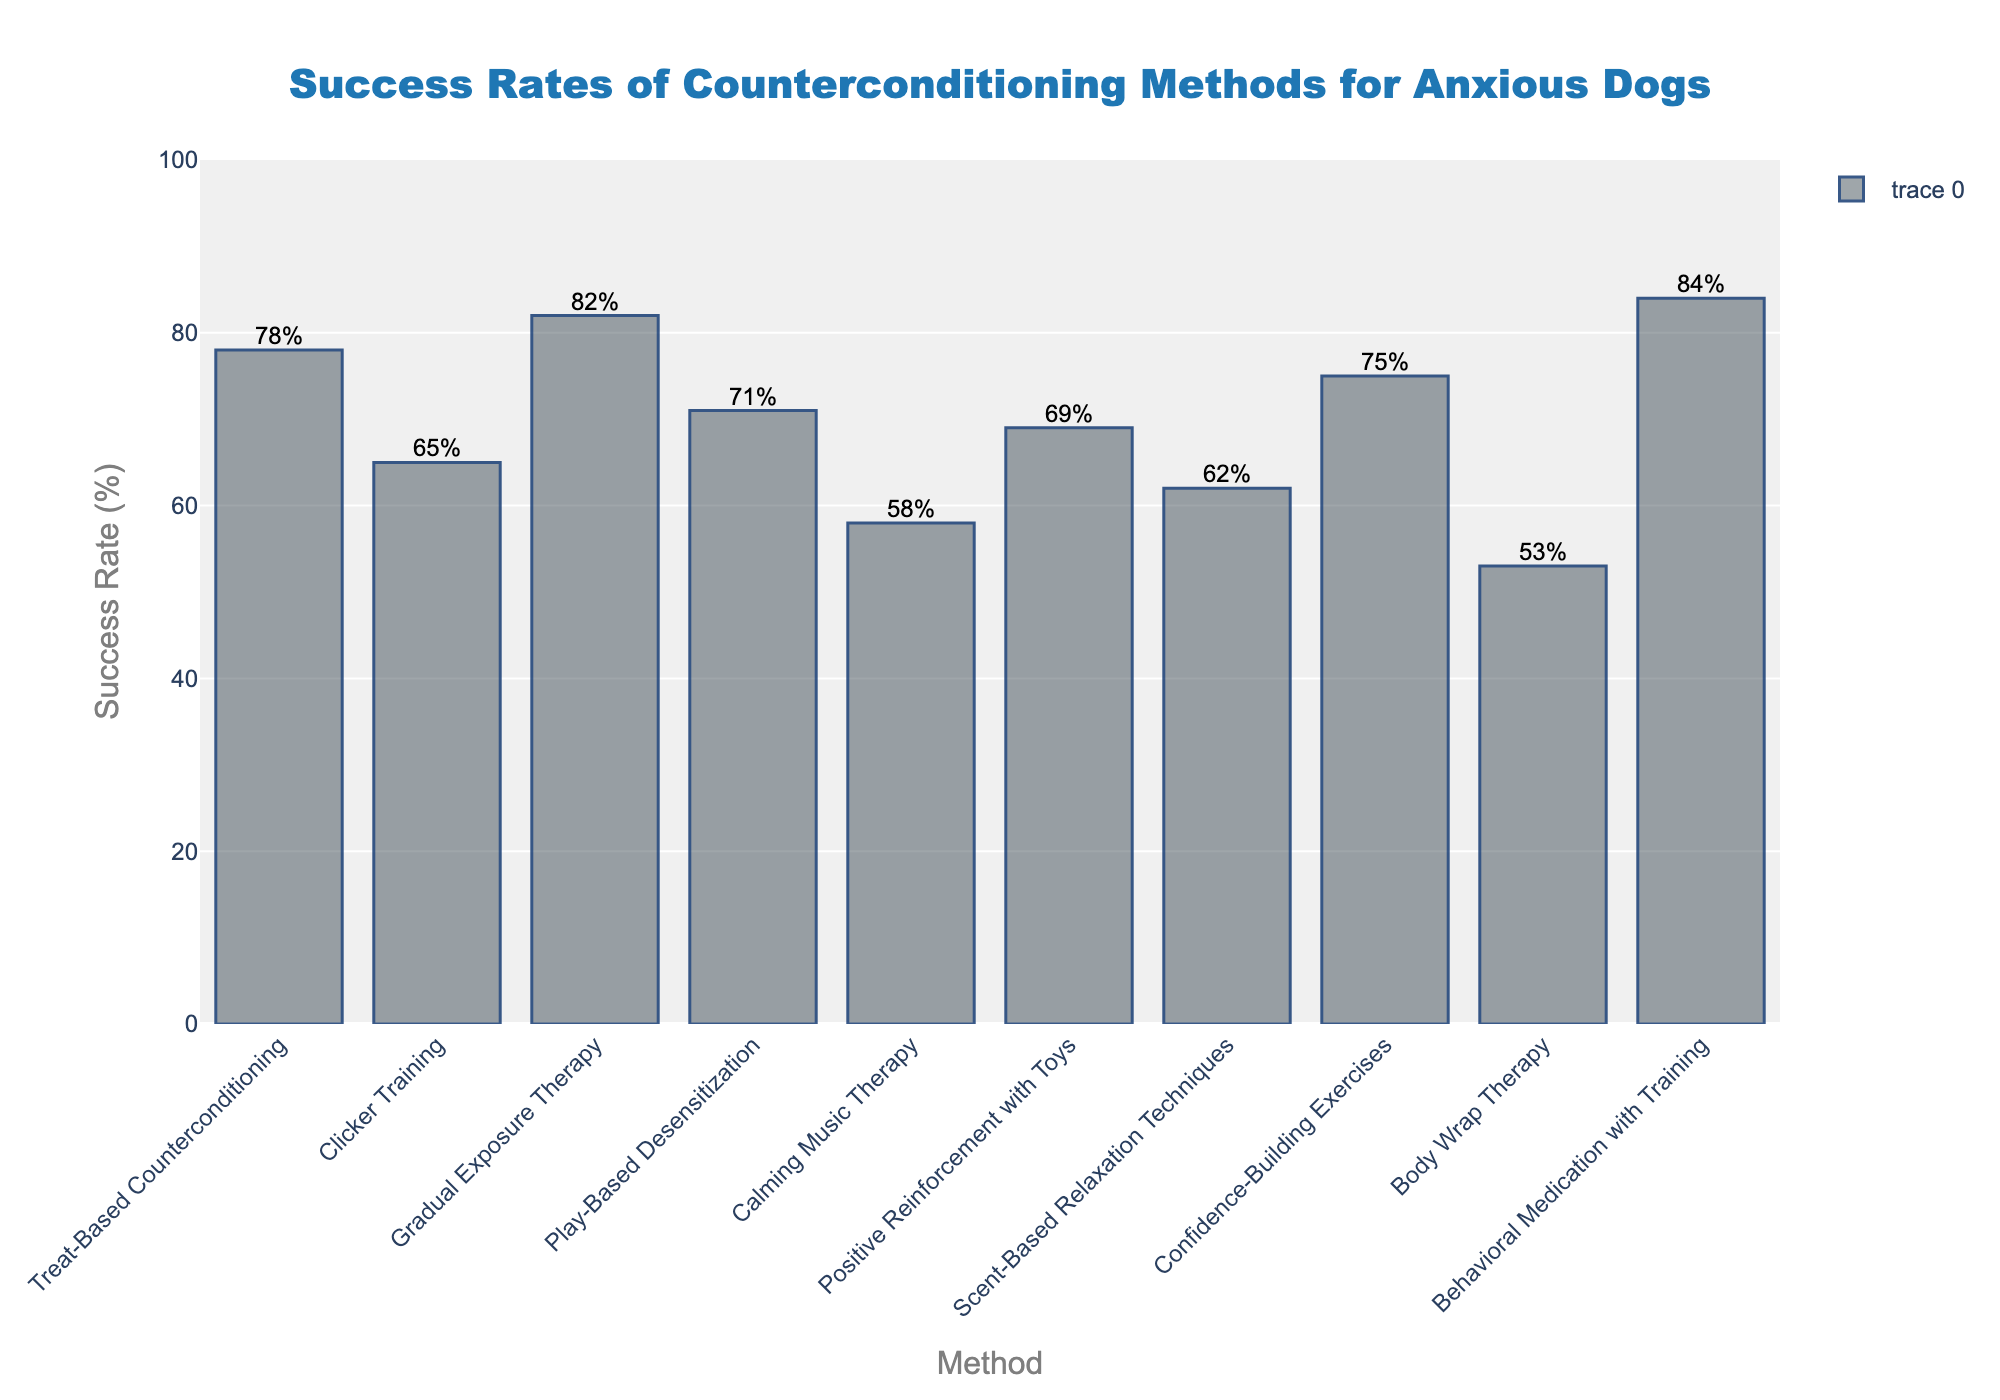What is the method with the highest success rate for counterconditioning? The method with the highest bar in the chart indicates the one with the highest success rate. The bar for Behavioral Medication with Training is the tallest.
Answer: Behavioral Medication with Training Which counterconditioning method has the lowest success rate? The method with the shortest bar represents the lowest success rate. The shortest bar corresponds to Body Wrap Therapy.
Answer: Body Wrap Therapy Which two methods have success rates closest to each other? By visually inspecting the bars of each method, look for two bars that are nearly the same height. Positive Reinforcement with Toys (69%) and Clicker Training (65%) have success rates that are close.
Answer: Positive Reinforcement with Toys and Clicker Training How much higher is the success rate of Gradual Exposure Therapy compared to Calming Music Therapy? Refer to the height of the bars for both methods. Gradual Exposure Therapy has a success rate of 82% and Calming Music Therapy has a rate of 58%. The difference is 82% - 58%.
Answer: 24% What is the average success rate of all the methods? Add the success rates of all methods and divide by the number of methods. (78 + 65 + 82 + 71 + 58 + 69 + 62 + 75 + 53 + 84) / 10 = 69.7%
Answer: 69.7% Which methods have a success rate greater than 70%? Identify bars that reach higher than the 70% mark on the y-axis and note their associated methods. The methods are Treat-Based Counterconditioning, Gradual Exposure Therapy, Behavioral Medication with Training, and Confidence-Building Exercises.
Answer: Treat-Based Counterconditioning, Gradual Exposure Therapy, Behavioral Medication with Training, Confidence-Building Exercises If you grouped the methods by success rates above or below 65%, how many methods fall into each group? Count the number of methods with success rates higher than 65% (including 65%) and less than 65%. There are 8 methods above 65% and 2 methods below 65%.
Answer: 8 above, 2 below What is the difference in success rate between the most effective and least effective method? Subtract the lowest success rate from the highest success rate. The highest is Behavioral Medication with Training (84%) and the lowest is Body Wrap Therapy (53%). The difference is 84% - 53%.
Answer: 31% Which method has a success rate directly in between Treat-Based Counterconditioning and Play-Based Desensitization? The success rates for Treat-Based Counterconditioning and Play-Based Desensitization are 78% and 71% respectively. The rate in between these two is 75%, which corresponds to Confidence-Building Exercises.
Answer: Confidence-Building Exercises 